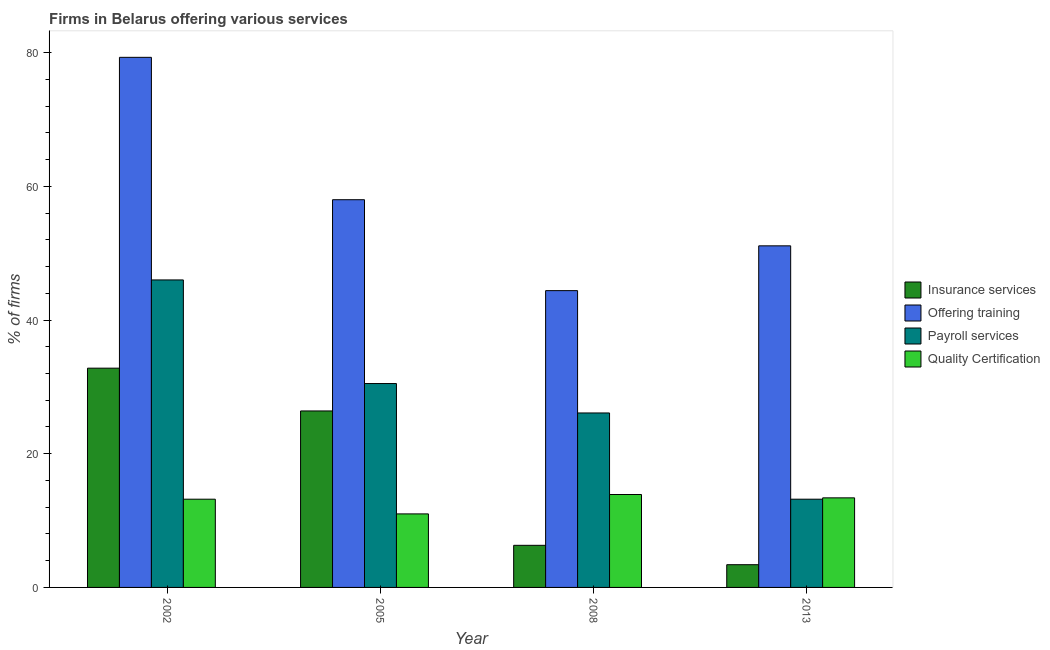Are the number of bars per tick equal to the number of legend labels?
Your response must be concise. Yes. How many bars are there on the 2nd tick from the left?
Provide a succinct answer. 4. What is the percentage of firms offering payroll services in 2013?
Your answer should be compact. 13.2. In which year was the percentage of firms offering quality certification maximum?
Your answer should be compact. 2008. In which year was the percentage of firms offering insurance services minimum?
Your answer should be very brief. 2013. What is the total percentage of firms offering quality certification in the graph?
Give a very brief answer. 51.5. What is the difference between the percentage of firms offering training in 2008 and that in 2013?
Your response must be concise. -6.7. What is the average percentage of firms offering payroll services per year?
Your answer should be compact. 28.95. In the year 2005, what is the difference between the percentage of firms offering insurance services and percentage of firms offering training?
Provide a succinct answer. 0. What is the ratio of the percentage of firms offering training in 2008 to that in 2013?
Your answer should be very brief. 0.87. Is the percentage of firms offering training in 2002 less than that in 2008?
Make the answer very short. No. Is the difference between the percentage of firms offering insurance services in 2002 and 2008 greater than the difference between the percentage of firms offering quality certification in 2002 and 2008?
Your response must be concise. No. What is the difference between the highest and the second highest percentage of firms offering insurance services?
Offer a terse response. 6.4. What is the difference between the highest and the lowest percentage of firms offering payroll services?
Provide a succinct answer. 32.8. In how many years, is the percentage of firms offering insurance services greater than the average percentage of firms offering insurance services taken over all years?
Keep it short and to the point. 2. What does the 2nd bar from the left in 2013 represents?
Offer a terse response. Offering training. What does the 3rd bar from the right in 2008 represents?
Keep it short and to the point. Offering training. How many bars are there?
Your answer should be compact. 16. How many years are there in the graph?
Keep it short and to the point. 4. Does the graph contain any zero values?
Make the answer very short. No. Does the graph contain grids?
Give a very brief answer. No. How many legend labels are there?
Make the answer very short. 4. How are the legend labels stacked?
Your response must be concise. Vertical. What is the title of the graph?
Provide a succinct answer. Firms in Belarus offering various services . Does "Natural Gas" appear as one of the legend labels in the graph?
Provide a short and direct response. No. What is the label or title of the X-axis?
Offer a very short reply. Year. What is the label or title of the Y-axis?
Ensure brevity in your answer.  % of firms. What is the % of firms in Insurance services in 2002?
Your response must be concise. 32.8. What is the % of firms in Offering training in 2002?
Your answer should be very brief. 79.3. What is the % of firms of Insurance services in 2005?
Keep it short and to the point. 26.4. What is the % of firms in Payroll services in 2005?
Your answer should be very brief. 30.5. What is the % of firms of Quality Certification in 2005?
Give a very brief answer. 11. What is the % of firms of Insurance services in 2008?
Offer a terse response. 6.3. What is the % of firms in Offering training in 2008?
Offer a very short reply. 44.4. What is the % of firms in Payroll services in 2008?
Offer a very short reply. 26.1. What is the % of firms in Insurance services in 2013?
Make the answer very short. 3.4. What is the % of firms of Offering training in 2013?
Your response must be concise. 51.1. Across all years, what is the maximum % of firms of Insurance services?
Your response must be concise. 32.8. Across all years, what is the maximum % of firms in Offering training?
Offer a very short reply. 79.3. Across all years, what is the maximum % of firms of Payroll services?
Offer a very short reply. 46. Across all years, what is the maximum % of firms of Quality Certification?
Offer a very short reply. 13.9. Across all years, what is the minimum % of firms of Insurance services?
Offer a terse response. 3.4. Across all years, what is the minimum % of firms of Offering training?
Your answer should be compact. 44.4. Across all years, what is the minimum % of firms in Quality Certification?
Provide a succinct answer. 11. What is the total % of firms in Insurance services in the graph?
Your answer should be compact. 68.9. What is the total % of firms of Offering training in the graph?
Make the answer very short. 232.8. What is the total % of firms in Payroll services in the graph?
Keep it short and to the point. 115.8. What is the total % of firms of Quality Certification in the graph?
Make the answer very short. 51.5. What is the difference between the % of firms in Offering training in 2002 and that in 2005?
Make the answer very short. 21.3. What is the difference between the % of firms of Payroll services in 2002 and that in 2005?
Provide a short and direct response. 15.5. What is the difference between the % of firms in Quality Certification in 2002 and that in 2005?
Make the answer very short. 2.2. What is the difference between the % of firms in Offering training in 2002 and that in 2008?
Your answer should be very brief. 34.9. What is the difference between the % of firms of Payroll services in 2002 and that in 2008?
Offer a terse response. 19.9. What is the difference between the % of firms of Insurance services in 2002 and that in 2013?
Provide a succinct answer. 29.4. What is the difference between the % of firms of Offering training in 2002 and that in 2013?
Provide a short and direct response. 28.2. What is the difference between the % of firms of Payroll services in 2002 and that in 2013?
Your response must be concise. 32.8. What is the difference between the % of firms in Insurance services in 2005 and that in 2008?
Keep it short and to the point. 20.1. What is the difference between the % of firms in Offering training in 2005 and that in 2008?
Your answer should be compact. 13.6. What is the difference between the % of firms of Payroll services in 2005 and that in 2008?
Give a very brief answer. 4.4. What is the difference between the % of firms in Quality Certification in 2005 and that in 2008?
Keep it short and to the point. -2.9. What is the difference between the % of firms of Payroll services in 2005 and that in 2013?
Offer a terse response. 17.3. What is the difference between the % of firms of Insurance services in 2008 and that in 2013?
Your response must be concise. 2.9. What is the difference between the % of firms in Offering training in 2008 and that in 2013?
Make the answer very short. -6.7. What is the difference between the % of firms of Payroll services in 2008 and that in 2013?
Ensure brevity in your answer.  12.9. What is the difference between the % of firms in Quality Certification in 2008 and that in 2013?
Offer a very short reply. 0.5. What is the difference between the % of firms in Insurance services in 2002 and the % of firms in Offering training in 2005?
Ensure brevity in your answer.  -25.2. What is the difference between the % of firms of Insurance services in 2002 and the % of firms of Quality Certification in 2005?
Give a very brief answer. 21.8. What is the difference between the % of firms in Offering training in 2002 and the % of firms in Payroll services in 2005?
Make the answer very short. 48.8. What is the difference between the % of firms in Offering training in 2002 and the % of firms in Quality Certification in 2005?
Ensure brevity in your answer.  68.3. What is the difference between the % of firms of Payroll services in 2002 and the % of firms of Quality Certification in 2005?
Your response must be concise. 35. What is the difference between the % of firms of Offering training in 2002 and the % of firms of Payroll services in 2008?
Make the answer very short. 53.2. What is the difference between the % of firms of Offering training in 2002 and the % of firms of Quality Certification in 2008?
Offer a very short reply. 65.4. What is the difference between the % of firms in Payroll services in 2002 and the % of firms in Quality Certification in 2008?
Your answer should be compact. 32.1. What is the difference between the % of firms in Insurance services in 2002 and the % of firms in Offering training in 2013?
Ensure brevity in your answer.  -18.3. What is the difference between the % of firms of Insurance services in 2002 and the % of firms of Payroll services in 2013?
Ensure brevity in your answer.  19.6. What is the difference between the % of firms in Insurance services in 2002 and the % of firms in Quality Certification in 2013?
Offer a terse response. 19.4. What is the difference between the % of firms of Offering training in 2002 and the % of firms of Payroll services in 2013?
Keep it short and to the point. 66.1. What is the difference between the % of firms of Offering training in 2002 and the % of firms of Quality Certification in 2013?
Your answer should be compact. 65.9. What is the difference between the % of firms in Payroll services in 2002 and the % of firms in Quality Certification in 2013?
Your answer should be compact. 32.6. What is the difference between the % of firms in Offering training in 2005 and the % of firms in Payroll services in 2008?
Your answer should be very brief. 31.9. What is the difference between the % of firms in Offering training in 2005 and the % of firms in Quality Certification in 2008?
Provide a succinct answer. 44.1. What is the difference between the % of firms in Payroll services in 2005 and the % of firms in Quality Certification in 2008?
Your answer should be compact. 16.6. What is the difference between the % of firms of Insurance services in 2005 and the % of firms of Offering training in 2013?
Offer a terse response. -24.7. What is the difference between the % of firms of Insurance services in 2005 and the % of firms of Payroll services in 2013?
Make the answer very short. 13.2. What is the difference between the % of firms in Insurance services in 2005 and the % of firms in Quality Certification in 2013?
Provide a short and direct response. 13. What is the difference between the % of firms of Offering training in 2005 and the % of firms of Payroll services in 2013?
Your answer should be compact. 44.8. What is the difference between the % of firms of Offering training in 2005 and the % of firms of Quality Certification in 2013?
Your response must be concise. 44.6. What is the difference between the % of firms of Payroll services in 2005 and the % of firms of Quality Certification in 2013?
Offer a terse response. 17.1. What is the difference between the % of firms in Insurance services in 2008 and the % of firms in Offering training in 2013?
Your answer should be compact. -44.8. What is the difference between the % of firms in Insurance services in 2008 and the % of firms in Payroll services in 2013?
Keep it short and to the point. -6.9. What is the difference between the % of firms of Insurance services in 2008 and the % of firms of Quality Certification in 2013?
Your answer should be compact. -7.1. What is the difference between the % of firms of Offering training in 2008 and the % of firms of Payroll services in 2013?
Your answer should be compact. 31.2. What is the average % of firms of Insurance services per year?
Keep it short and to the point. 17.23. What is the average % of firms in Offering training per year?
Offer a terse response. 58.2. What is the average % of firms of Payroll services per year?
Give a very brief answer. 28.95. What is the average % of firms of Quality Certification per year?
Give a very brief answer. 12.88. In the year 2002, what is the difference between the % of firms of Insurance services and % of firms of Offering training?
Provide a short and direct response. -46.5. In the year 2002, what is the difference between the % of firms in Insurance services and % of firms in Payroll services?
Provide a short and direct response. -13.2. In the year 2002, what is the difference between the % of firms of Insurance services and % of firms of Quality Certification?
Provide a succinct answer. 19.6. In the year 2002, what is the difference between the % of firms of Offering training and % of firms of Payroll services?
Ensure brevity in your answer.  33.3. In the year 2002, what is the difference between the % of firms in Offering training and % of firms in Quality Certification?
Offer a terse response. 66.1. In the year 2002, what is the difference between the % of firms of Payroll services and % of firms of Quality Certification?
Offer a very short reply. 32.8. In the year 2005, what is the difference between the % of firms of Insurance services and % of firms of Offering training?
Make the answer very short. -31.6. In the year 2005, what is the difference between the % of firms in Insurance services and % of firms in Quality Certification?
Offer a very short reply. 15.4. In the year 2005, what is the difference between the % of firms of Offering training and % of firms of Quality Certification?
Keep it short and to the point. 47. In the year 2005, what is the difference between the % of firms in Payroll services and % of firms in Quality Certification?
Keep it short and to the point. 19.5. In the year 2008, what is the difference between the % of firms in Insurance services and % of firms in Offering training?
Offer a very short reply. -38.1. In the year 2008, what is the difference between the % of firms of Insurance services and % of firms of Payroll services?
Your answer should be compact. -19.8. In the year 2008, what is the difference between the % of firms of Offering training and % of firms of Payroll services?
Offer a terse response. 18.3. In the year 2008, what is the difference between the % of firms of Offering training and % of firms of Quality Certification?
Your response must be concise. 30.5. In the year 2013, what is the difference between the % of firms in Insurance services and % of firms in Offering training?
Your response must be concise. -47.7. In the year 2013, what is the difference between the % of firms in Insurance services and % of firms in Quality Certification?
Provide a succinct answer. -10. In the year 2013, what is the difference between the % of firms in Offering training and % of firms in Payroll services?
Your response must be concise. 37.9. In the year 2013, what is the difference between the % of firms in Offering training and % of firms in Quality Certification?
Provide a succinct answer. 37.7. What is the ratio of the % of firms of Insurance services in 2002 to that in 2005?
Offer a very short reply. 1.24. What is the ratio of the % of firms in Offering training in 2002 to that in 2005?
Offer a terse response. 1.37. What is the ratio of the % of firms in Payroll services in 2002 to that in 2005?
Provide a short and direct response. 1.51. What is the ratio of the % of firms in Insurance services in 2002 to that in 2008?
Make the answer very short. 5.21. What is the ratio of the % of firms of Offering training in 2002 to that in 2008?
Your answer should be compact. 1.79. What is the ratio of the % of firms in Payroll services in 2002 to that in 2008?
Keep it short and to the point. 1.76. What is the ratio of the % of firms of Quality Certification in 2002 to that in 2008?
Ensure brevity in your answer.  0.95. What is the ratio of the % of firms in Insurance services in 2002 to that in 2013?
Provide a succinct answer. 9.65. What is the ratio of the % of firms in Offering training in 2002 to that in 2013?
Offer a very short reply. 1.55. What is the ratio of the % of firms of Payroll services in 2002 to that in 2013?
Make the answer very short. 3.48. What is the ratio of the % of firms in Quality Certification in 2002 to that in 2013?
Give a very brief answer. 0.99. What is the ratio of the % of firms of Insurance services in 2005 to that in 2008?
Offer a terse response. 4.19. What is the ratio of the % of firms in Offering training in 2005 to that in 2008?
Ensure brevity in your answer.  1.31. What is the ratio of the % of firms of Payroll services in 2005 to that in 2008?
Provide a short and direct response. 1.17. What is the ratio of the % of firms of Quality Certification in 2005 to that in 2008?
Your answer should be very brief. 0.79. What is the ratio of the % of firms of Insurance services in 2005 to that in 2013?
Keep it short and to the point. 7.76. What is the ratio of the % of firms of Offering training in 2005 to that in 2013?
Ensure brevity in your answer.  1.14. What is the ratio of the % of firms of Payroll services in 2005 to that in 2013?
Offer a terse response. 2.31. What is the ratio of the % of firms of Quality Certification in 2005 to that in 2013?
Provide a short and direct response. 0.82. What is the ratio of the % of firms in Insurance services in 2008 to that in 2013?
Ensure brevity in your answer.  1.85. What is the ratio of the % of firms in Offering training in 2008 to that in 2013?
Your answer should be compact. 0.87. What is the ratio of the % of firms of Payroll services in 2008 to that in 2013?
Your answer should be very brief. 1.98. What is the ratio of the % of firms in Quality Certification in 2008 to that in 2013?
Your answer should be compact. 1.04. What is the difference between the highest and the second highest % of firms in Offering training?
Your response must be concise. 21.3. What is the difference between the highest and the second highest % of firms in Quality Certification?
Your answer should be very brief. 0.5. What is the difference between the highest and the lowest % of firms of Insurance services?
Your answer should be very brief. 29.4. What is the difference between the highest and the lowest % of firms of Offering training?
Keep it short and to the point. 34.9. What is the difference between the highest and the lowest % of firms of Payroll services?
Provide a short and direct response. 32.8. 